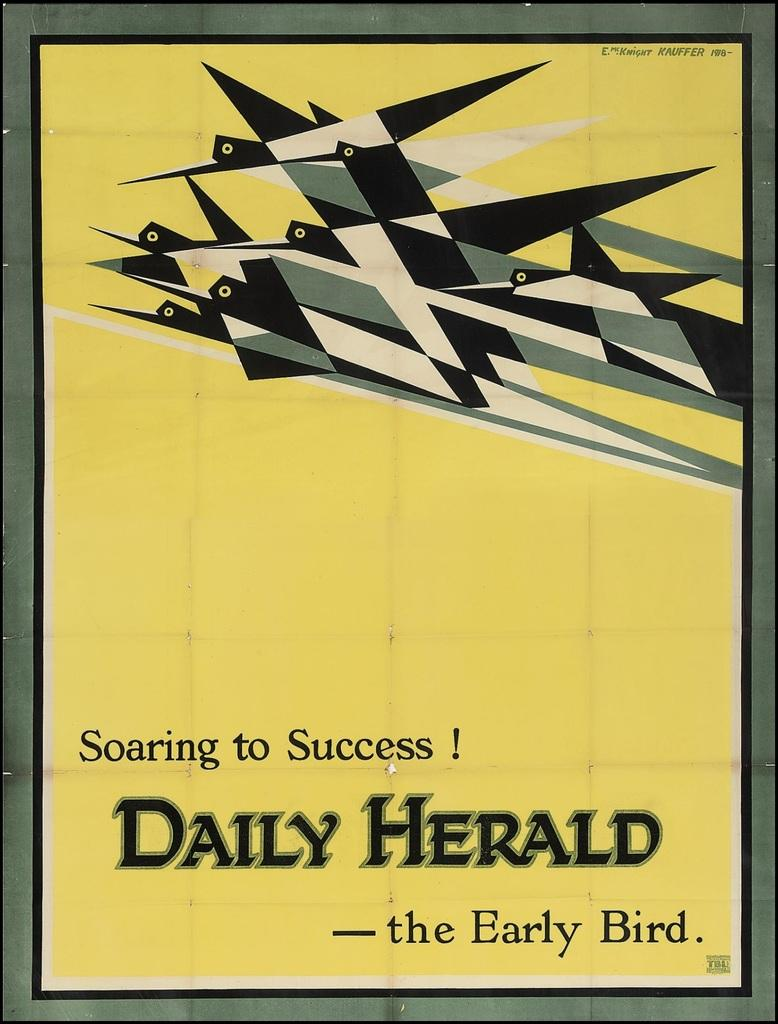Provide a one-sentence caption for the provided image. The poster shown is from the Daily Herald. 